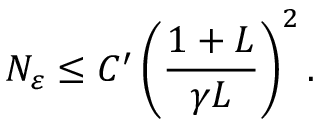Convert formula to latex. <formula><loc_0><loc_0><loc_500><loc_500>N _ { \varepsilon } \leq C ^ { \prime } \left ( \frac { 1 + L } { \gamma L } \right ) ^ { 2 } .</formula> 